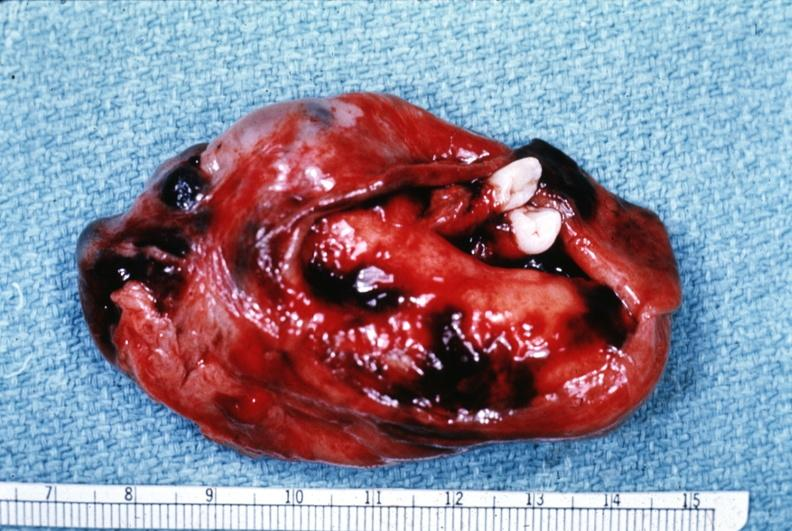s 70yof present?
Answer the question using a single word or phrase. No 